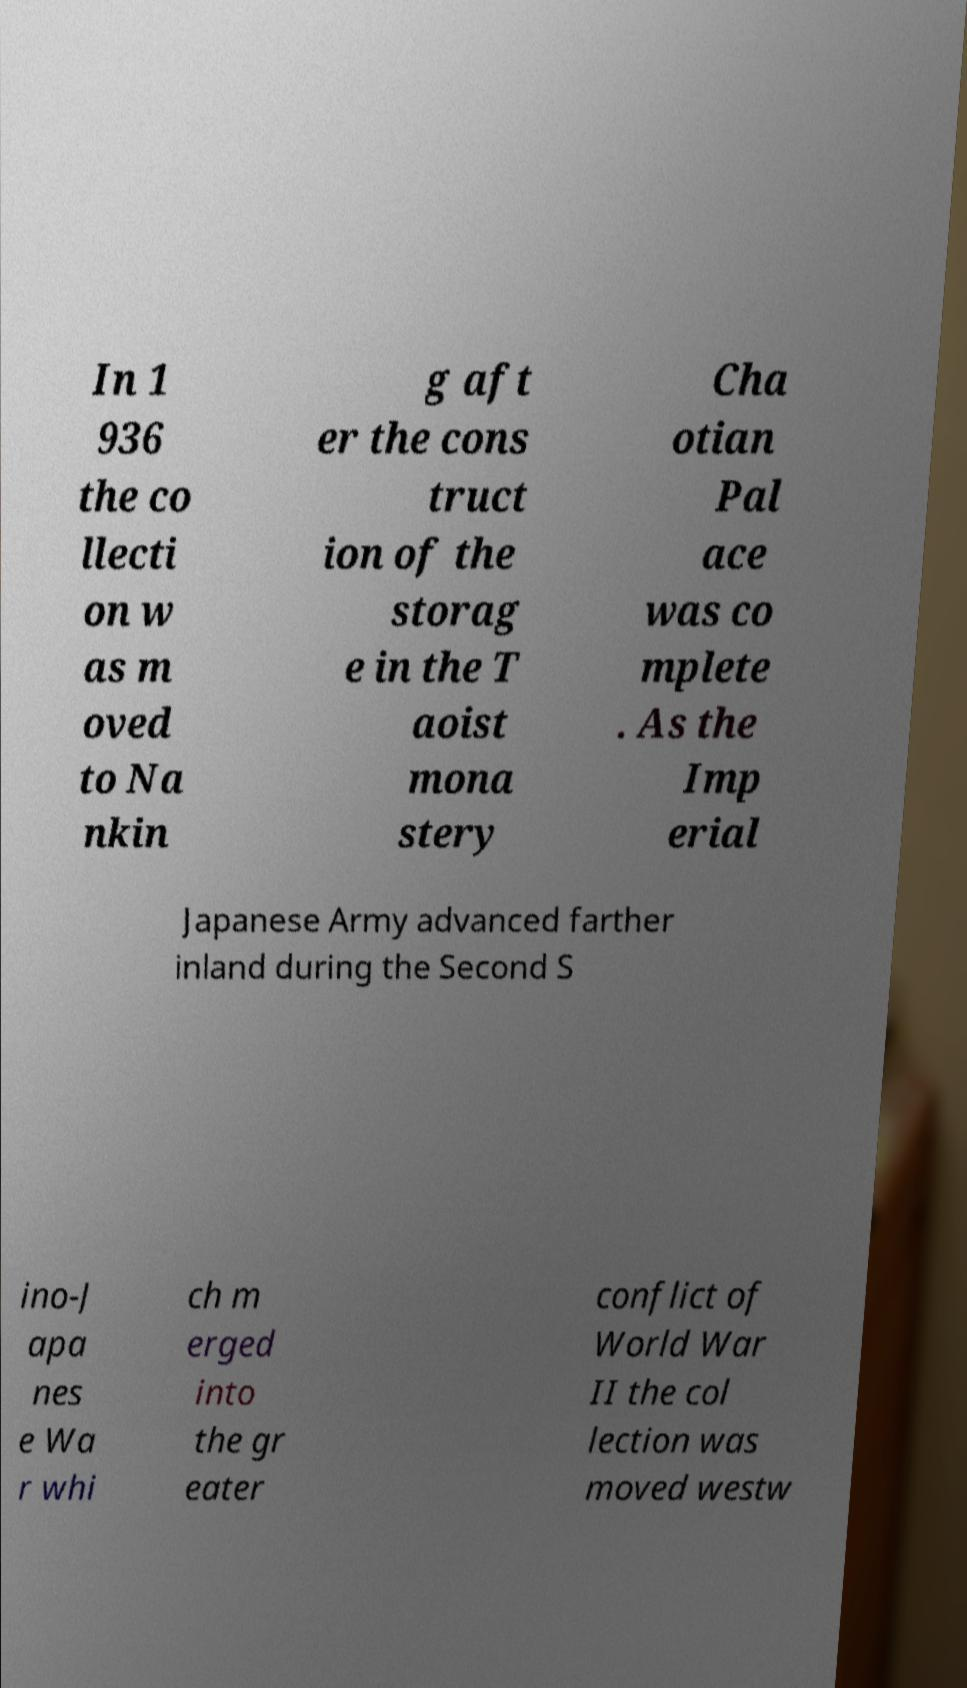Can you read and provide the text displayed in the image?This photo seems to have some interesting text. Can you extract and type it out for me? In 1 936 the co llecti on w as m oved to Na nkin g aft er the cons truct ion of the storag e in the T aoist mona stery Cha otian Pal ace was co mplete . As the Imp erial Japanese Army advanced farther inland during the Second S ino-J apa nes e Wa r whi ch m erged into the gr eater conflict of World War II the col lection was moved westw 